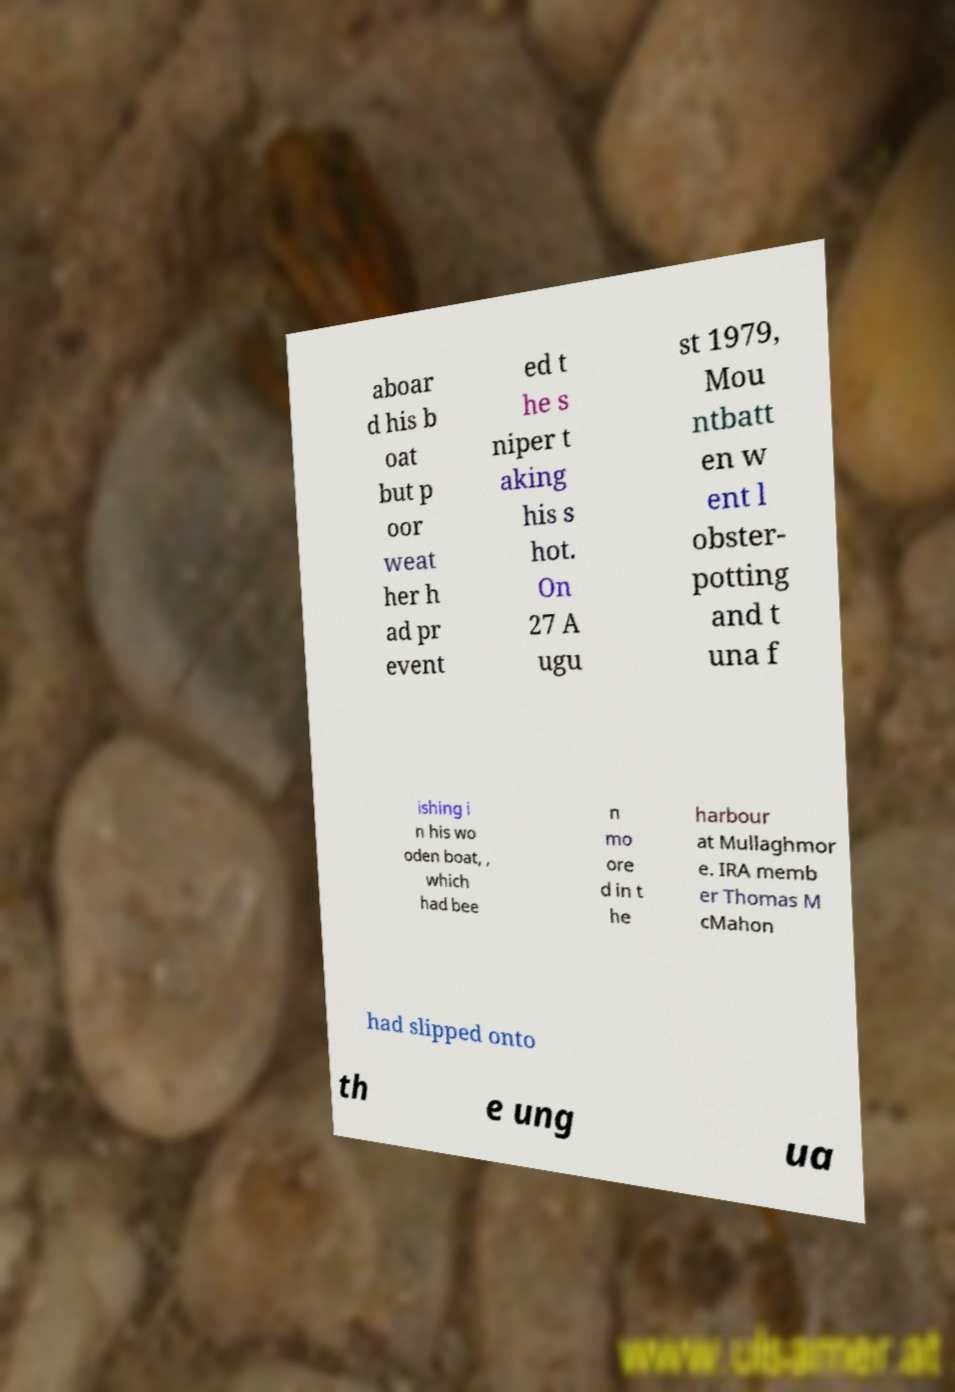Could you extract and type out the text from this image? aboar d his b oat but p oor weat her h ad pr event ed t he s niper t aking his s hot. On 27 A ugu st 1979, Mou ntbatt en w ent l obster- potting and t una f ishing i n his wo oden boat, , which had bee n mo ore d in t he harbour at Mullaghmor e. IRA memb er Thomas M cMahon had slipped onto th e ung ua 